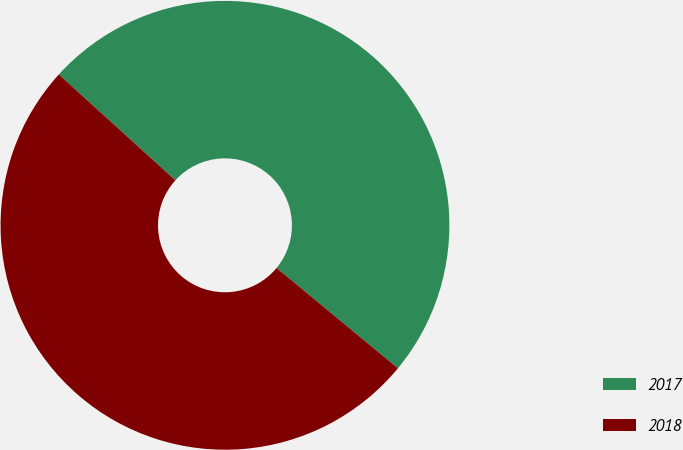Convert chart to OTSL. <chart><loc_0><loc_0><loc_500><loc_500><pie_chart><fcel>2017<fcel>2018<nl><fcel>49.26%<fcel>50.74%<nl></chart> 